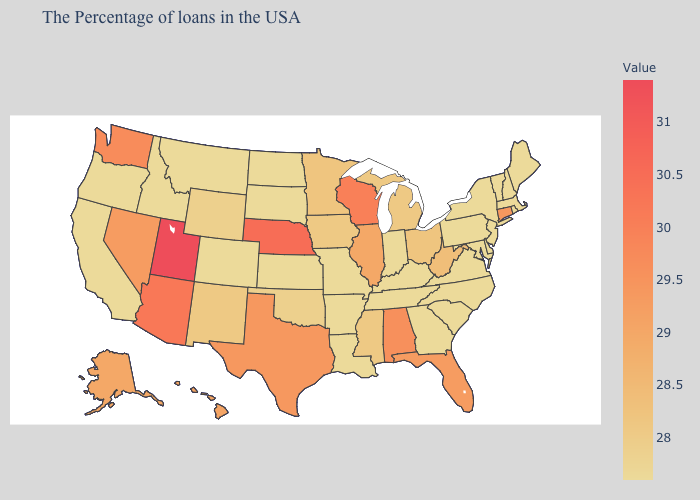Does Oklahoma have the lowest value in the USA?
Write a very short answer. No. Among the states that border Kentucky , which have the lowest value?
Answer briefly. Virginia, Indiana, Tennessee, Missouri. Among the states that border Florida , does Alabama have the highest value?
Answer briefly. Yes. Among the states that border Texas , does Louisiana have the lowest value?
Short answer required. Yes. Does Utah have the highest value in the West?
Write a very short answer. Yes. Which states have the lowest value in the MidWest?
Answer briefly. Indiana, Missouri, Kansas, South Dakota, North Dakota. 